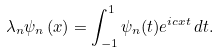Convert formula to latex. <formula><loc_0><loc_0><loc_500><loc_500>\lambda _ { n } \psi _ { n } \left ( x \right ) = \int _ { - 1 } ^ { 1 } \psi _ { n } ( t ) e ^ { i c x t } \, d t .</formula> 